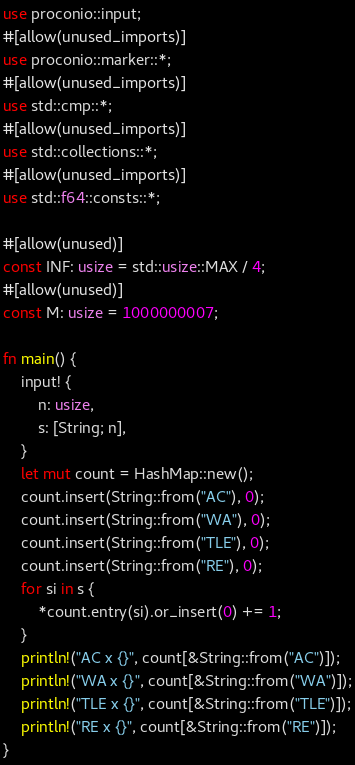Convert code to text. <code><loc_0><loc_0><loc_500><loc_500><_Rust_>use proconio::input;
#[allow(unused_imports)]
use proconio::marker::*;
#[allow(unused_imports)]
use std::cmp::*;
#[allow(unused_imports)]
use std::collections::*;
#[allow(unused_imports)]
use std::f64::consts::*;

#[allow(unused)]
const INF: usize = std::usize::MAX / 4;
#[allow(unused)]
const M: usize = 1000000007;

fn main() {
    input! {
        n: usize,
        s: [String; n],
    }
    let mut count = HashMap::new();
    count.insert(String::from("AC"), 0);
    count.insert(String::from("WA"), 0);
    count.insert(String::from("TLE"), 0);
    count.insert(String::from("RE"), 0);
    for si in s {
        *count.entry(si).or_insert(0) += 1;
    }
    println!("AC x {}", count[&String::from("AC")]);
    println!("WA x {}", count[&String::from("WA")]);
    println!("TLE x {}", count[&String::from("TLE")]);
    println!("RE x {}", count[&String::from("RE")]);
}
</code> 